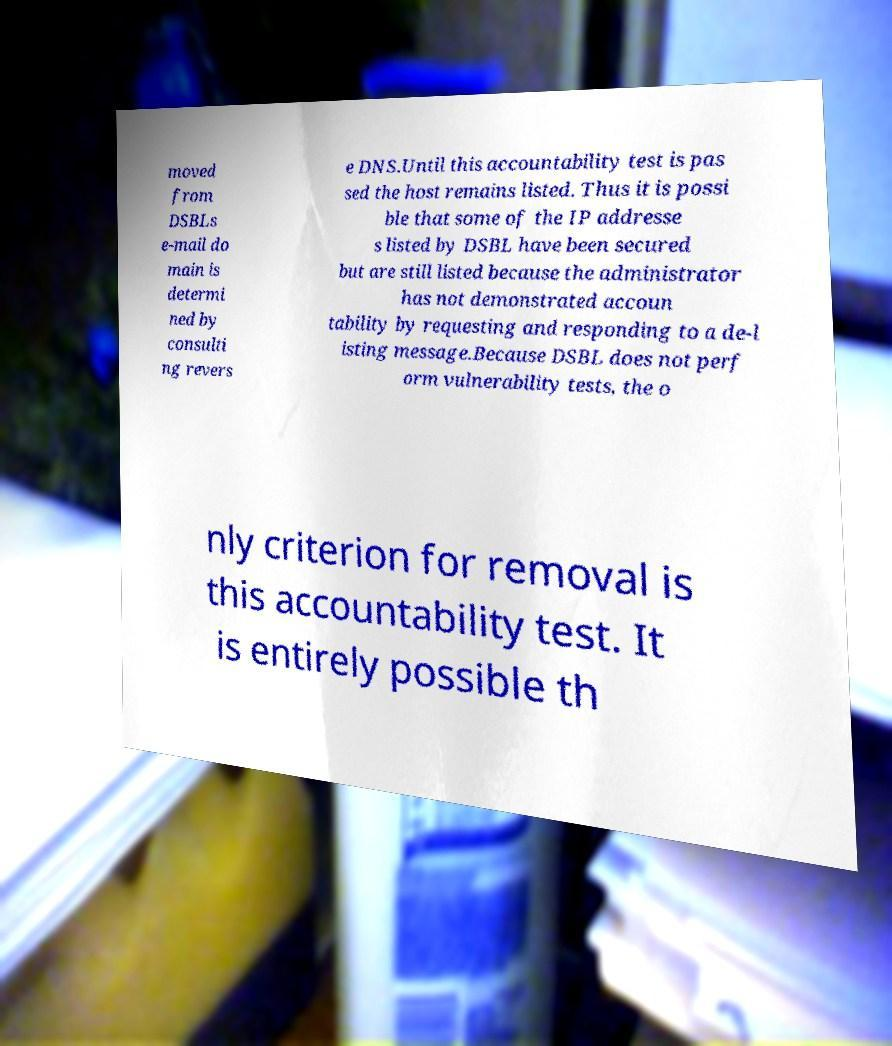Can you accurately transcribe the text from the provided image for me? moved from DSBLs e-mail do main is determi ned by consulti ng revers e DNS.Until this accountability test is pas sed the host remains listed. Thus it is possi ble that some of the IP addresse s listed by DSBL have been secured but are still listed because the administrator has not demonstrated accoun tability by requesting and responding to a de-l isting message.Because DSBL does not perf orm vulnerability tests, the o nly criterion for removal is this accountability test. It is entirely possible th 